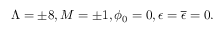<formula> <loc_0><loc_0><loc_500><loc_500>\Lambda = \pm 8 , M = \pm 1 , \phi _ { 0 } = 0 , \epsilon = { \overline { \epsilon } } = 0 .</formula> 